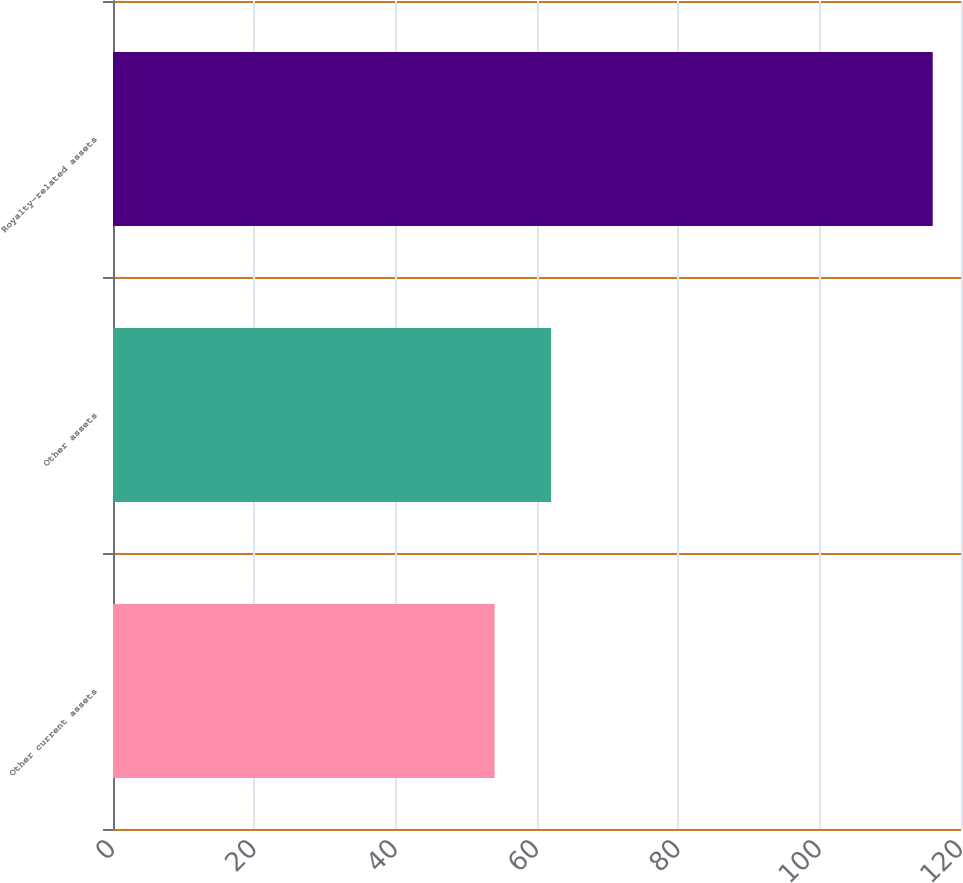Convert chart to OTSL. <chart><loc_0><loc_0><loc_500><loc_500><bar_chart><fcel>Other current assets<fcel>Other assets<fcel>Royalty-related assets<nl><fcel>54<fcel>62<fcel>116<nl></chart> 